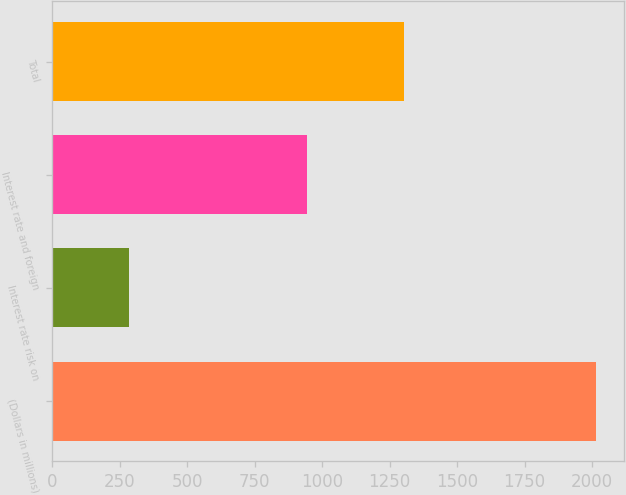Convert chart to OTSL. <chart><loc_0><loc_0><loc_500><loc_500><bar_chart><fcel>(Dollars in millions)<fcel>Interest rate risk on<fcel>Interest rate and foreign<fcel>Total<nl><fcel>2016<fcel>286<fcel>944<fcel>1304<nl></chart> 